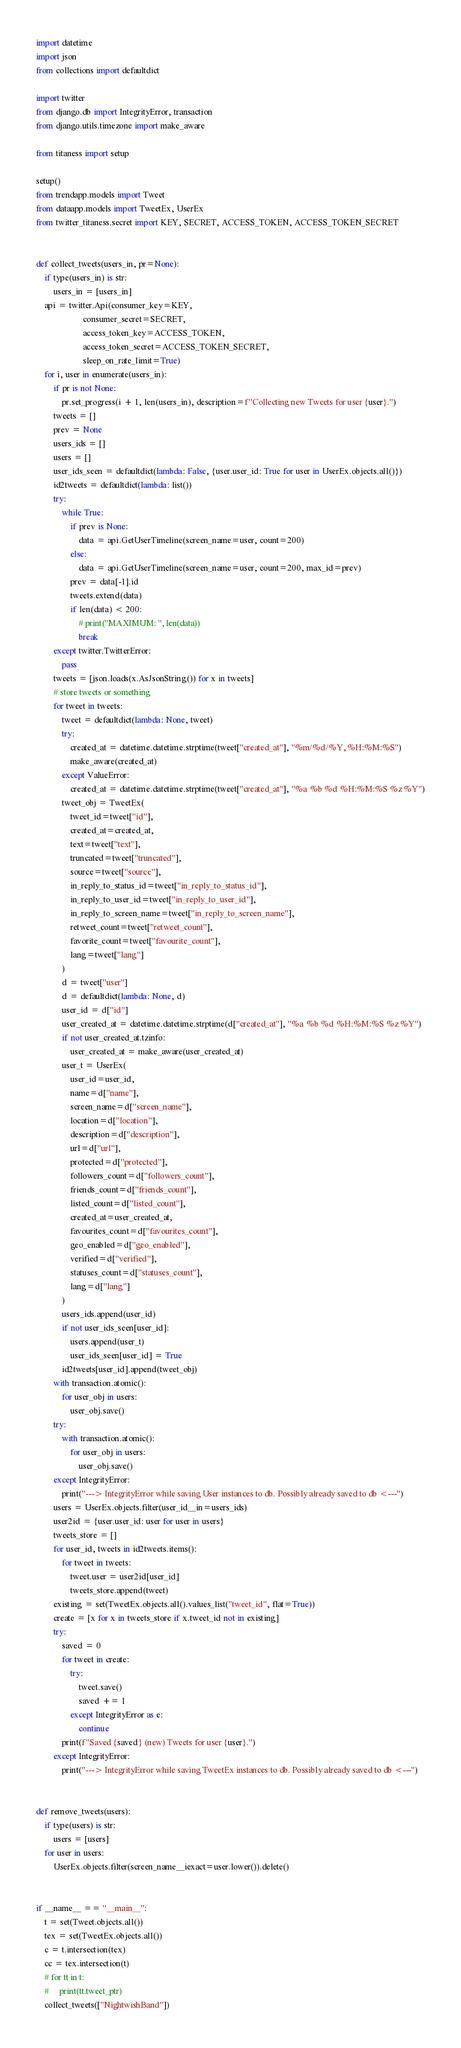<code> <loc_0><loc_0><loc_500><loc_500><_Python_>import datetime
import json
from collections import defaultdict

import twitter
from django.db import IntegrityError, transaction
from django.utils.timezone import make_aware

from titaness import setup

setup()
from trendapp.models import Tweet
from dataapp.models import TweetEx, UserEx
from twitter_titaness.secret import KEY, SECRET, ACCESS_TOKEN, ACCESS_TOKEN_SECRET


def collect_tweets(users_in, pr=None):
    if type(users_in) is str:
        users_in = [users_in]
    api = twitter.Api(consumer_key=KEY,
                      consumer_secret=SECRET,
                      access_token_key=ACCESS_TOKEN,
                      access_token_secret=ACCESS_TOKEN_SECRET,
                      sleep_on_rate_limit=True)
    for i, user in enumerate(users_in):
        if pr is not None:
            pr.set_progress(i + 1, len(users_in), description=f"Collecting new Tweets for user {user}.")
        tweets = []
        prev = None
        users_ids = []
        users = []
        user_ids_seen = defaultdict(lambda: False, {user.user_id: True for user in UserEx.objects.all()})
        id2tweets = defaultdict(lambda: list())
        try:
            while True:
                if prev is None:
                    data = api.GetUserTimeline(screen_name=user, count=200)
                else:
                    data = api.GetUserTimeline(screen_name=user, count=200, max_id=prev)
                prev = data[-1].id
                tweets.extend(data)
                if len(data) < 200:
                    # print("MAXIMUM: ", len(data))
                    break
        except twitter.TwitterError:
            pass
        tweets = [json.loads(x.AsJsonString()) for x in tweets]
        # store tweets or something
        for tweet in tweets:
            tweet = defaultdict(lambda: None, tweet)
            try:
                created_at = datetime.datetime.strptime(tweet["created_at"], "%m/%d/%Y, %H:%M:%S")
                make_aware(created_at)
            except ValueError:
                created_at = datetime.datetime.strptime(tweet["created_at"], "%a %b %d %H:%M:%S %z %Y")
            tweet_obj = TweetEx(
                tweet_id=tweet["id"],
                created_at=created_at,
                text=tweet["text"],
                truncated=tweet["truncated"],
                source=tweet["source"],
                in_reply_to_status_id=tweet["in_reply_to_status_id"],
                in_reply_to_user_id=tweet["in_reply_to_user_id"],
                in_reply_to_screen_name=tweet["in_reply_to_screen_name"],
                retweet_count=tweet["retweet_count"],
                favorite_count=tweet["favourite_count"],
                lang=tweet["lang"]
            )
            d = tweet["user"]
            d = defaultdict(lambda: None, d)
            user_id = d["id"]
            user_created_at = datetime.datetime.strptime(d["created_at"], "%a %b %d %H:%M:%S %z %Y")
            if not user_created_at.tzinfo:
                user_created_at = make_aware(user_created_at)
            user_t = UserEx(
                user_id=user_id,
                name=d["name"],
                screen_name=d["screen_name"],
                location=d["location"],
                description=d["description"],
                url=d["url"],
                protected=d["protected"],
                followers_count=d["followers_count"],
                friends_count=d["friends_count"],
                listed_count=d["listed_count"],
                created_at=user_created_at,
                favourites_count=d["favourites_count"],
                geo_enabled=d["geo_enabled"],
                verified=d["verified"],
                statuses_count=d["statuses_count"],
                lang=d["lang"]
            )
            users_ids.append(user_id)
            if not user_ids_seen[user_id]:
                users.append(user_t)
                user_ids_seen[user_id] = True
            id2tweets[user_id].append(tweet_obj)
        with transaction.atomic():
            for user_obj in users:
                user_obj.save()
        try:
            with transaction.atomic():
                for user_obj in users:
                    user_obj.save()
        except IntegrityError:
            print("---> IntegrityError while saving User instances to db. Possibly already saved to db <---")
        users = UserEx.objects.filter(user_id__in=users_ids)
        user2id = {user.user_id: user for user in users}
        tweets_store = []
        for user_id, tweets in id2tweets.items():
            for tweet in tweets:
                tweet.user = user2id[user_id]
                tweets_store.append(tweet)
        existing = set(TweetEx.objects.all().values_list("tweet_id", flat=True))
        create = [x for x in tweets_store if x.tweet_id not in existing]
        try:
            saved = 0
            for tweet in create:
                try:
                    tweet.save()
                    saved += 1
                except IntegrityError as e:
                    continue
            print(f"Saved {saved} (new) Tweets for user {user}.")
        except IntegrityError:
            print("---> IntegrityError while saving TweetEx instances to db. Possibly already saved to db <---")


def remove_tweets(users):
    if type(users) is str:
        users = [users]
    for user in users:
        UserEx.objects.filter(screen_name__iexact=user.lower()).delete()


if __name__ == "__main__":
    t = set(Tweet.objects.all())
    tex = set(TweetEx.objects.all())
    c = t.intersection(tex)
    cc = tex.intersection(t)
    # for tt in t:
    #     print(tt.tweet_ptr)
    collect_tweets(["NightwishBand"])
</code> 